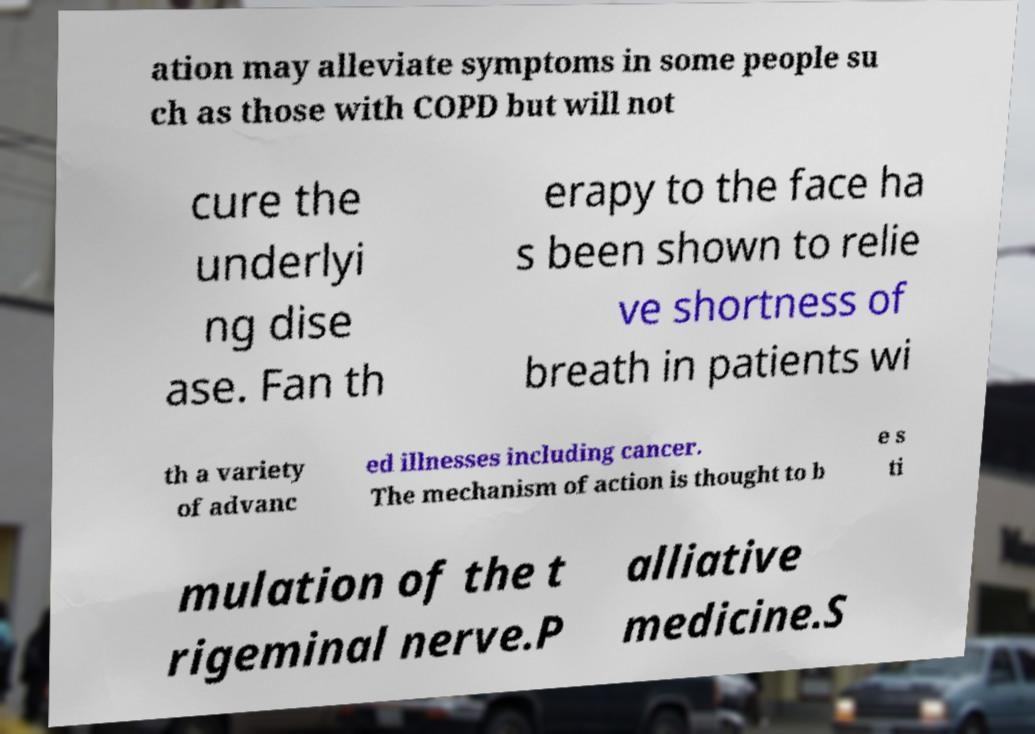Can you read and provide the text displayed in the image?This photo seems to have some interesting text. Can you extract and type it out for me? ation may alleviate symptoms in some people su ch as those with COPD but will not cure the underlyi ng dise ase. Fan th erapy to the face ha s been shown to relie ve shortness of breath in patients wi th a variety of advanc ed illnesses including cancer. The mechanism of action is thought to b e s ti mulation of the t rigeminal nerve.P alliative medicine.S 